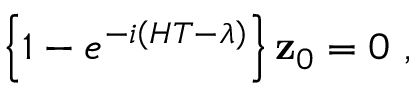Convert formula to latex. <formula><loc_0><loc_0><loc_500><loc_500>\left \{ 1 - e ^ { - i \left ( H T - \lambda \right ) } \right \} { z } _ { 0 } = 0 \ ,</formula> 